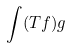<formula> <loc_0><loc_0><loc_500><loc_500>\int ( T f ) g</formula> 